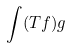<formula> <loc_0><loc_0><loc_500><loc_500>\int ( T f ) g</formula> 